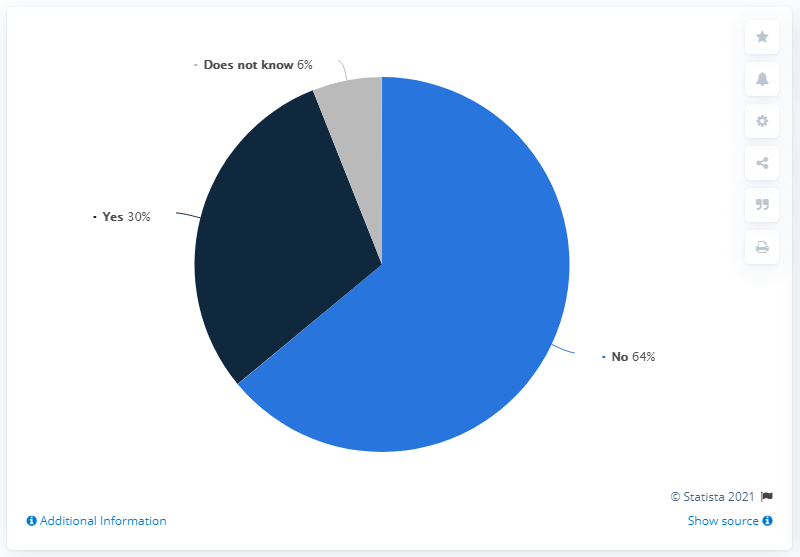Highlight a few significant elements in this photo. The ratio of the navy blue segment to the smallest segment is 10.67... The pie chart uses three colors. 